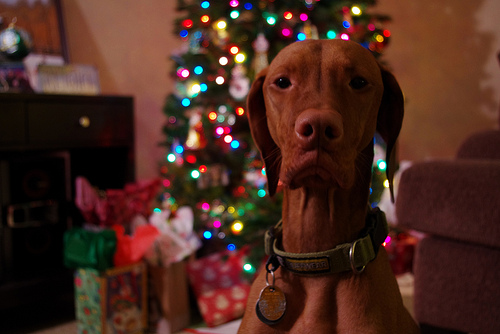<image>
Is the dog to the right of the christmas tree? No. The dog is not to the right of the christmas tree. The horizontal positioning shows a different relationship. 